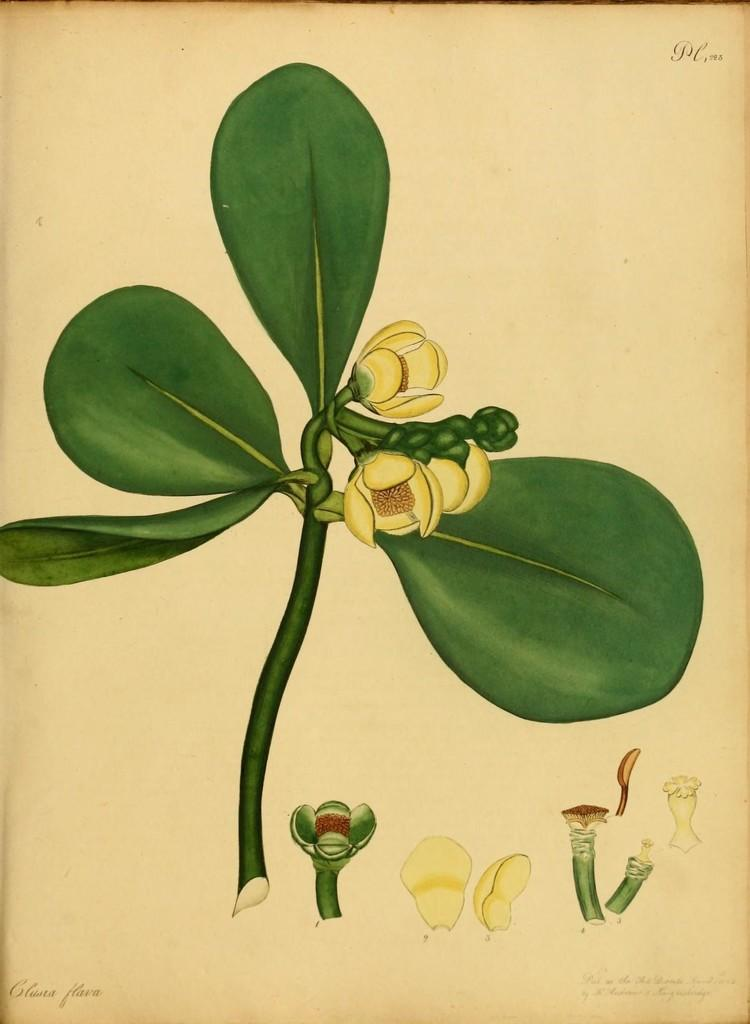What is present on the paper in the image? There are words, images of flowers, images of leaves, and images of stems on the paper. Can you describe the content of the paper? The paper contains words and various images related to plants, including flowers, leaves, and stems. What type of shock can be seen affecting the paper in the image? There is no shock present in the image; the paper appears to be unaffected. 